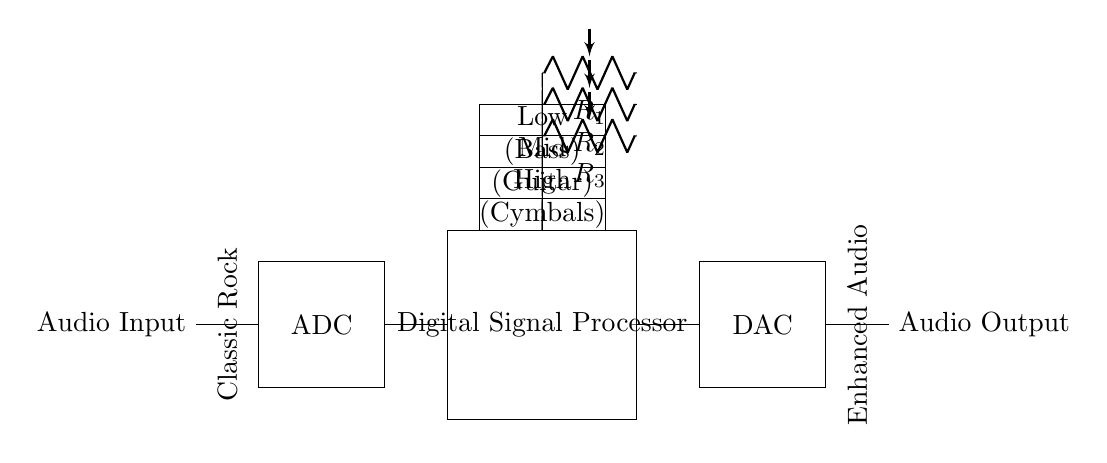What component converts the audio input to a digital signal? The circuit shows an ADC (Analog-to-Digital Converter) that is specifically designed to convert the incoming analog audio signal into a digital format, which is necessary for processing in a digital equalizer.
Answer: ADC What are the three frequency bands represented in the equalizer? The circuit diagram indicates three bands categorized as Low (Bass), Mid (Guitar), and High (Cymbals). Each of these bands enhances specific parts of the audio spectrum to improve playback quality for classic rock music.
Answer: Low, Mid, High What is the role of the Digital Signal Processor in this circuit? The Digital Signal Processor (DSP) processes the digital audio signal received from the ADC. It applies filtering and adjustments to the frequency bands to enhance the overall audio output, crucial for tailoring the listening experience.
Answer: Processing How many resistors are shown in the circuit? In the circuit diagram, there are three resistors labeled as R_1, R_2, and R_3. Each of these resistors is associated with one of the frequency bands to control the gain and response of the equalizer for optimal sound output.
Answer: 3 What does the DAC do in this circuit? The DAC (Digital-to-Analog Converter) in this circuit converts the processed digital audio signal back into an analog signal, allowing it to be sent to speakers or other audio output devices for listening.
Answer: Converts signal Which signal is labeled as "Enhanced Audio"? The output after the DAC is labeled "Audio Output." This denotes that the processed signal has been modified for improved playback with enhanced audio quality, resulting in what is referred to as "Enhanced Audio."
Answer: Audio Output What musical genre is emphasized in the diagram's annotations? The annotations in the circuit diagram highlight "Classic Rock," indicating that the design of this digital equalizer circuit is tailored specifically to enhance playback for this genre of music, ensuring that it's well represented through the equalization settings.
Answer: Classic Rock 